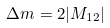<formula> <loc_0><loc_0><loc_500><loc_500>\Delta m = 2 | M _ { 1 2 } |</formula> 